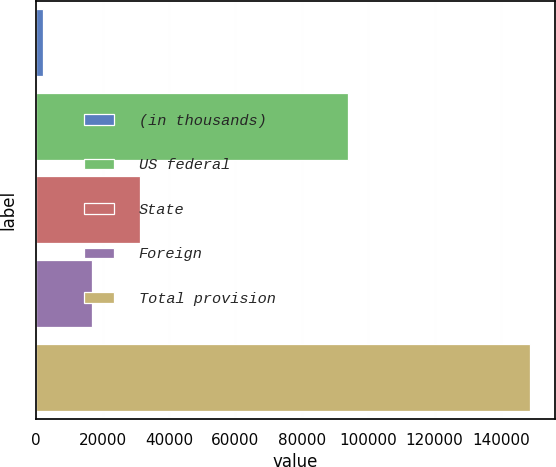Convert chart. <chart><loc_0><loc_0><loc_500><loc_500><bar_chart><fcel>(in thousands)<fcel>US federal<fcel>State<fcel>Foreign<fcel>Total provision<nl><fcel>2009<fcel>93794<fcel>31350.2<fcel>16679.6<fcel>148715<nl></chart> 